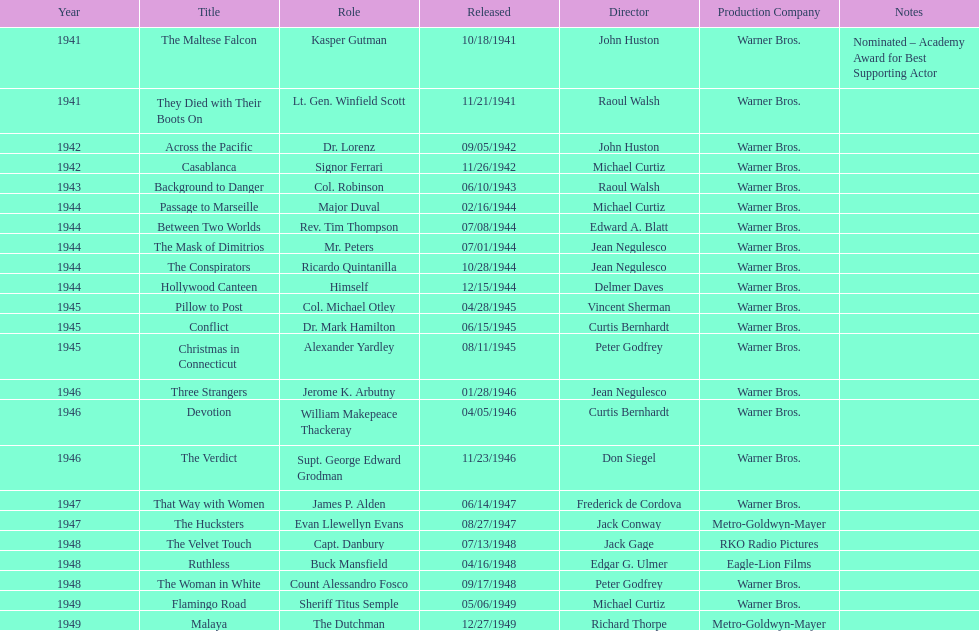What were the first and last movies greenstreet acted in? The Maltese Falcon, Malaya. 